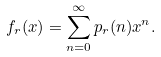Convert formula to latex. <formula><loc_0><loc_0><loc_500><loc_500>f _ { r } ( x ) = \sum _ { n = 0 } ^ { \infty } p _ { r } ( n ) x ^ { n } .</formula> 